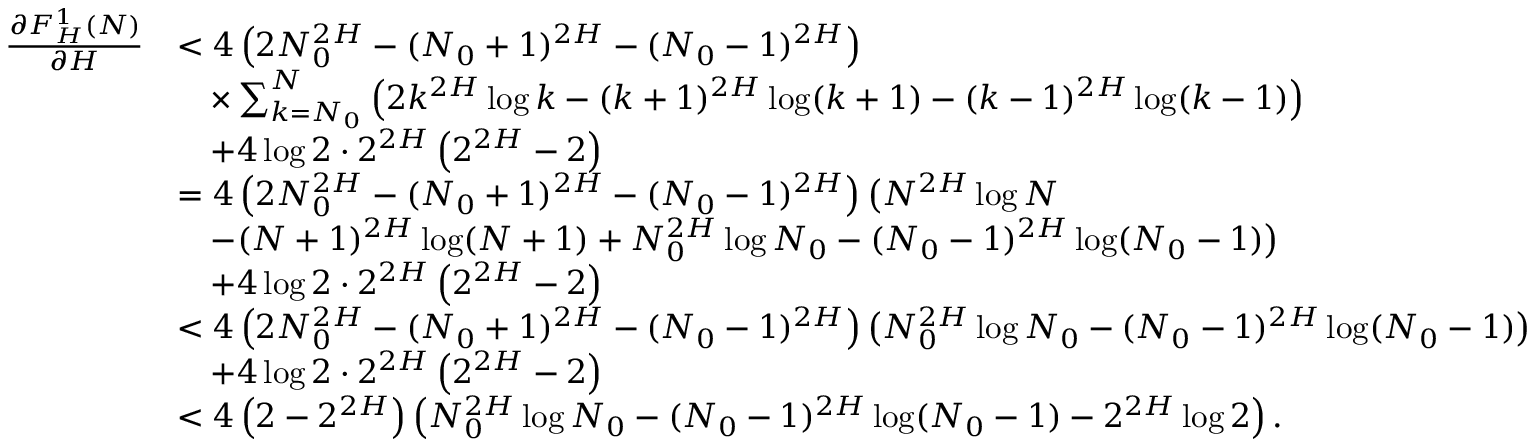<formula> <loc_0><loc_0><loc_500><loc_500>\begin{array} { r l } { \frac { \partial F _ { H } ^ { 1 } ( N ) } { \partial H } } & { < 4 \left ( 2 N _ { 0 } ^ { 2 H } - ( N _ { 0 } + 1 ) ^ { 2 H } - ( N _ { 0 } - 1 ) ^ { 2 H } \right ) } \\ & { \quad \times \sum _ { k = N _ { 0 } } ^ { N } \left ( 2 k ^ { 2 H } \log k - ( k + 1 ) ^ { 2 H } \log ( k + 1 ) - ( k - 1 ) ^ { 2 H } \log ( k - 1 ) \right ) } \\ & { \quad + 4 \log 2 \cdot 2 ^ { 2 H } \left ( 2 ^ { 2 H } - 2 \right ) } \\ & { = 4 \left ( 2 N _ { 0 } ^ { 2 H } - ( N _ { 0 } + 1 ) ^ { 2 H } - ( N _ { 0 } - 1 ) ^ { 2 H } \right ) \left ( N ^ { 2 H } \log N } \\ & { \quad - ( N + 1 ) ^ { 2 H } \log ( N + 1 ) + N _ { 0 } ^ { 2 H } \log N _ { 0 } - ( N _ { 0 } - 1 ) ^ { 2 H } \log ( N _ { 0 } - 1 ) \right ) } \\ & { \quad + 4 \log 2 \cdot 2 ^ { 2 H } \left ( 2 ^ { 2 H } - 2 \right ) } \\ & { < 4 \left ( 2 N _ { 0 } ^ { 2 H } - ( N _ { 0 } + 1 ) ^ { 2 H } - ( N _ { 0 } - 1 ) ^ { 2 H } \right ) \left ( N _ { 0 } ^ { 2 H } \log N _ { 0 } - ( N _ { 0 } - 1 ) ^ { 2 H } \log ( N _ { 0 } - 1 ) \right ) } \\ & { \quad + 4 \log 2 \cdot 2 ^ { 2 H } \left ( 2 ^ { 2 H } - 2 \right ) } \\ & { < 4 \left ( 2 - 2 ^ { 2 H } \right ) \left ( N _ { 0 } ^ { 2 H } \log N _ { 0 } - ( N _ { 0 } - 1 ) ^ { 2 H } \log ( N _ { 0 } - 1 ) - 2 ^ { 2 H } \log 2 \right ) . } \end{array}</formula> 